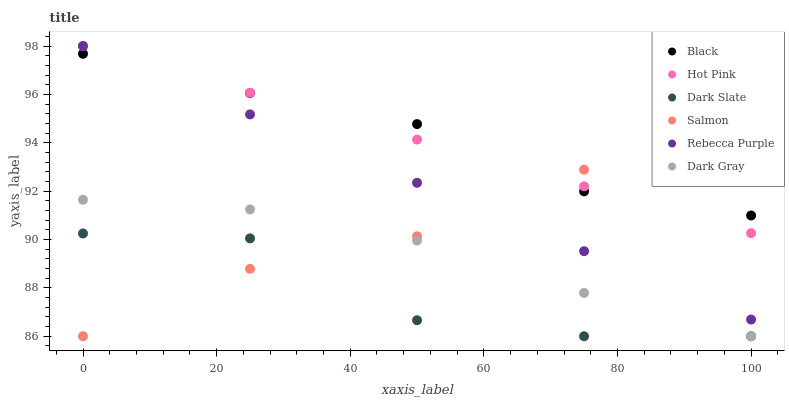Does Dark Slate have the minimum area under the curve?
Answer yes or no. Yes. Does Black have the maximum area under the curve?
Answer yes or no. Yes. Does Salmon have the minimum area under the curve?
Answer yes or no. No. Does Salmon have the maximum area under the curve?
Answer yes or no. No. Is Rebecca Purple the smoothest?
Answer yes or no. Yes. Is Dark Slate the roughest?
Answer yes or no. Yes. Is Salmon the smoothest?
Answer yes or no. No. Is Salmon the roughest?
Answer yes or no. No. Does Salmon have the lowest value?
Answer yes or no. Yes. Does Black have the lowest value?
Answer yes or no. No. Does Rebecca Purple have the highest value?
Answer yes or no. Yes. Does Salmon have the highest value?
Answer yes or no. No. Is Dark Slate less than Hot Pink?
Answer yes or no. Yes. Is Black greater than Dark Slate?
Answer yes or no. Yes. Does Salmon intersect Hot Pink?
Answer yes or no. Yes. Is Salmon less than Hot Pink?
Answer yes or no. No. Is Salmon greater than Hot Pink?
Answer yes or no. No. Does Dark Slate intersect Hot Pink?
Answer yes or no. No. 